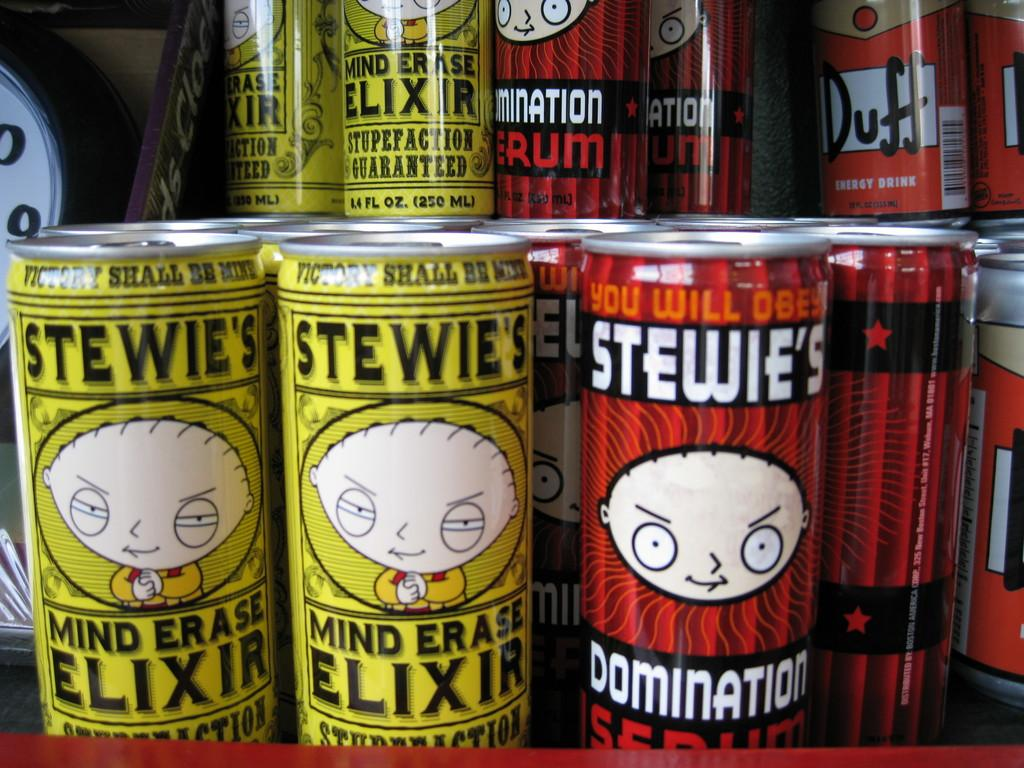<image>
Provide a brief description of the given image. Quite a few cans of energy drinks, mainly Stewie's Mind Erase Elixir and Elimination Serum, are on display. 